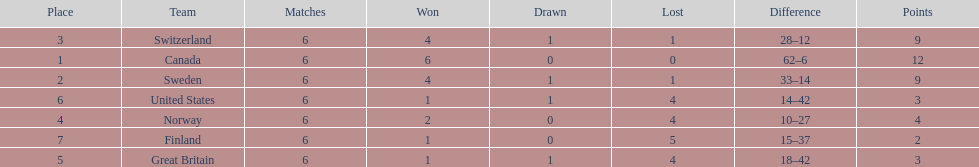What is the total number of teams to have 4 total wins? 2. 